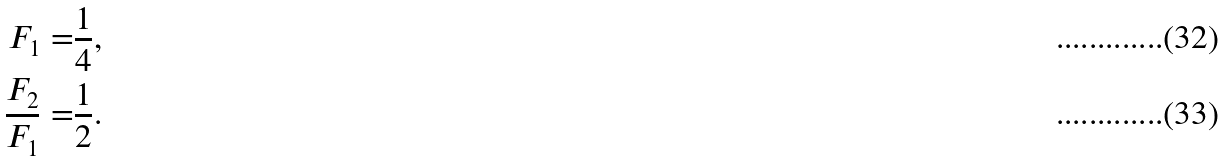Convert formula to latex. <formula><loc_0><loc_0><loc_500><loc_500>F _ { 1 } = & \frac { 1 } { 4 } , \\ \frac { F _ { 2 } } { F _ { 1 } } = & \frac { 1 } { 2 } .</formula> 